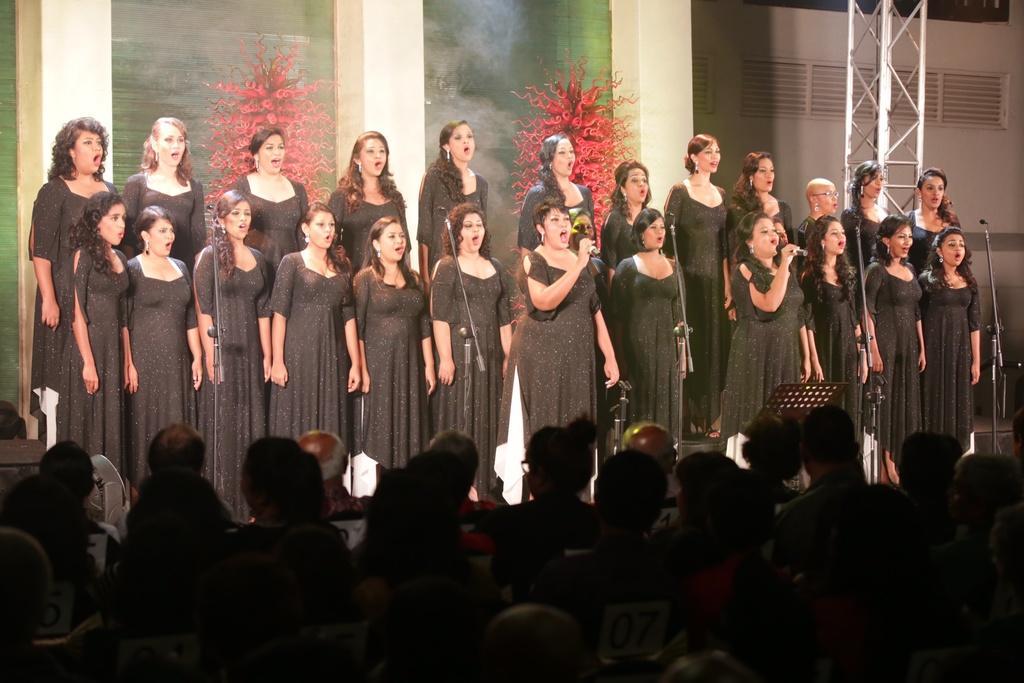Describe this image in one or two sentences. In this image on the stage many ladies are singing. They all are wearing black dress. In front of them there are mics. In the foreground there are audience. In the background there is a wall and a pillar. 